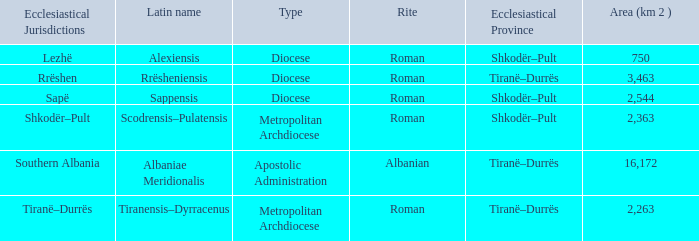What ecclesiastical province is associated with a type diocese and has the latin alias "alexiensis"? Shkodër–Pult. 